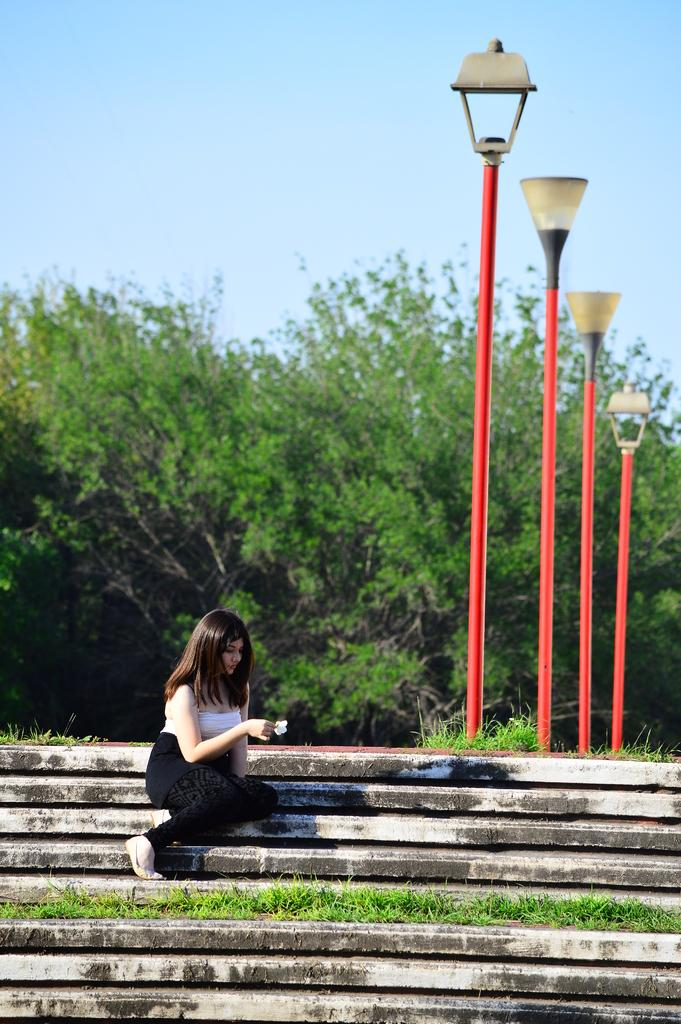What is the person in the image doing? There is a person sitting on the stairs in the image. What can be seen in the background behind the person? Green trees and light poles are visible in the background. What color is the sky in the image? The sky is blue in the image. Can you hear the sound of thunder in the image? There is no sound present in the image, so it is not possible to hear thunder or any other sounds. 